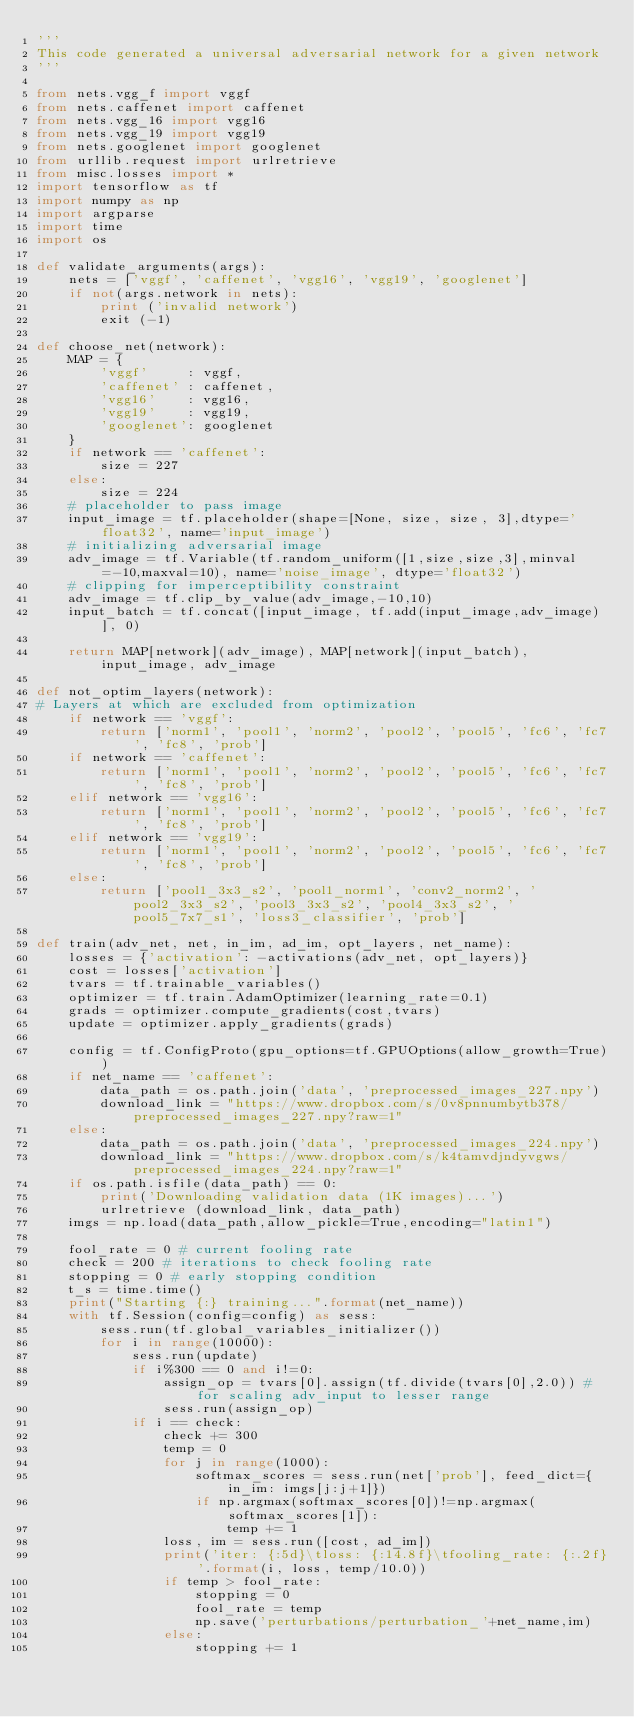Convert code to text. <code><loc_0><loc_0><loc_500><loc_500><_Python_>'''
This code generated a universal adversarial network for a given network
'''

from nets.vgg_f import vggf
from nets.caffenet import caffenet
from nets.vgg_16 import vgg16
from nets.vgg_19 import vgg19
from nets.googlenet import googlenet
from urllib.request import urlretrieve
from misc.losses import *
import tensorflow as tf
import numpy as np
import argparse
import time
import os

def validate_arguments(args):
    nets = ['vggf', 'caffenet', 'vgg16', 'vgg19', 'googlenet']
    if not(args.network in nets):
        print ('invalid network')
        exit (-1)

def choose_net(network):
    MAP = {
        'vggf'     : vggf,
        'caffenet' : caffenet,
        'vgg16'    : vgg16,
        'vgg19'    : vgg19,
        'googlenet': googlenet
    }
    if network == 'caffenet':
        size = 227
    else:
        size = 224
    # placeholder to pass image
    input_image = tf.placeholder(shape=[None, size, size, 3],dtype='float32', name='input_image')
    # initializing adversarial image
    adv_image = tf.Variable(tf.random_uniform([1,size,size,3],minval=-10,maxval=10), name='noise_image', dtype='float32')
    # clipping for imperceptibility constraint
    adv_image = tf.clip_by_value(adv_image,-10,10)
    input_batch = tf.concat([input_image, tf.add(input_image,adv_image)], 0)

    return MAP[network](adv_image), MAP[network](input_batch), input_image, adv_image

def not_optim_layers(network):
# Layers at which are excluded from optimization
    if network == 'vggf':
        return ['norm1', 'pool1', 'norm2', 'pool2', 'pool5', 'fc6', 'fc7', 'fc8', 'prob']
    if network == 'caffenet':
        return ['norm1', 'pool1', 'norm2', 'pool2', 'pool5', 'fc6', 'fc7', 'fc8', 'prob']
    elif network == 'vgg16':
        return ['norm1', 'pool1', 'norm2', 'pool2', 'pool5', 'fc6', 'fc7', 'fc8', 'prob']
    elif network == 'vgg19':
        return ['norm1', 'pool1', 'norm2', 'pool2', 'pool5', 'fc6', 'fc7', 'fc8', 'prob']
    else:
        return ['pool1_3x3_s2', 'pool1_norm1', 'conv2_norm2', 'pool2_3x3_s2', 'pool3_3x3_s2', 'pool4_3x3_s2', 'pool5_7x7_s1', 'loss3_classifier', 'prob']

def train(adv_net, net, in_im, ad_im, opt_layers, net_name):
    losses = {'activation': -activations(adv_net, opt_layers)}
    cost = losses['activation']
    tvars = tf.trainable_variables()
    optimizer = tf.train.AdamOptimizer(learning_rate=0.1)
    grads = optimizer.compute_gradients(cost,tvars)
    update = optimizer.apply_gradients(grads)

    config = tf.ConfigProto(gpu_options=tf.GPUOptions(allow_growth=True))
    if net_name == 'caffenet':
        data_path = os.path.join('data', 'preprocessed_images_227.npy')
        download_link = "https://www.dropbox.com/s/0v8pnnumbytb378/preprocessed_images_227.npy?raw=1"
    else:
        data_path = os.path.join('data', 'preprocessed_images_224.npy')
        download_link = "https://www.dropbox.com/s/k4tamvdjndyvgws/preprocessed_images_224.npy?raw=1"
    if os.path.isfile(data_path) == 0:
        print('Downloading validation data (1K images)...')
        urlretrieve (download_link, data_path)
    imgs = np.load(data_path,allow_pickle=True,encoding="latin1")

    fool_rate = 0 # current fooling rate
    check = 200 # iterations to check fooling rate
    stopping = 0 # early stopping condition
    t_s = time.time()
    print("Starting {:} training...".format(net_name))
    with tf.Session(config=config) as sess:
        sess.run(tf.global_variables_initializer())
        for i in range(10000):
            sess.run(update)
            if i%300 == 0 and i!=0:
                assign_op = tvars[0].assign(tf.divide(tvars[0],2.0)) #for scaling adv_input to lesser range
                sess.run(assign_op)
            if i == check:
                check += 300
                temp = 0
                for j in range(1000):
                    softmax_scores = sess.run(net['prob'], feed_dict={in_im: imgs[j:j+1]})
                    if np.argmax(softmax_scores[0])!=np.argmax(softmax_scores[1]):
                        temp += 1
                loss, im = sess.run([cost, ad_im])
                print('iter: {:5d}\tloss: {:14.8f}\tfooling_rate: {:.2f}'.format(i, loss, temp/10.0))
                if temp > fool_rate:
                    stopping = 0
                    fool_rate = temp
                    np.save('perturbations/perturbation_'+net_name,im)
                else:
                    stopping += 1</code> 